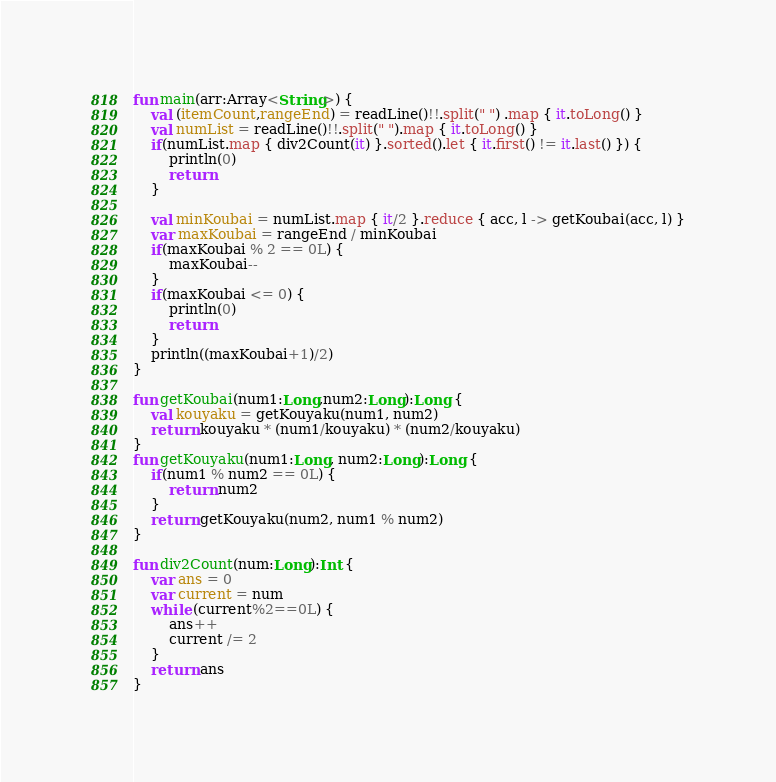<code> <loc_0><loc_0><loc_500><loc_500><_Kotlin_>
fun main(arr:Array<String>) {
    val (itemCount,rangeEnd) = readLine()!!.split(" ") .map { it.toLong() }
    val numList = readLine()!!.split(" ").map { it.toLong() }
    if(numList.map { div2Count(it) }.sorted().let { it.first() != it.last() }) {
        println(0)
        return
    }

    val minKoubai = numList.map { it/2 }.reduce { acc, l -> getKoubai(acc, l) }
    var maxKoubai = rangeEnd / minKoubai
    if(maxKoubai % 2 == 0L) {
        maxKoubai--
    }
    if(maxKoubai <= 0) {
        println(0)
        return
    }
    println((maxKoubai+1)/2)
}

fun getKoubai(num1:Long,num2:Long):Long {
    val kouyaku = getKouyaku(num1, num2)
    return kouyaku * (num1/kouyaku) * (num2/kouyaku)
}
fun getKouyaku(num1:Long, num2:Long):Long {
    if(num1 % num2 == 0L) {
        return num2
    }
    return getKouyaku(num2, num1 % num2)
}

fun div2Count(num:Long):Int {
    var ans = 0
    var current = num
    while (current%2==0L) {
        ans++
        current /= 2
    }
    return ans
}
</code> 